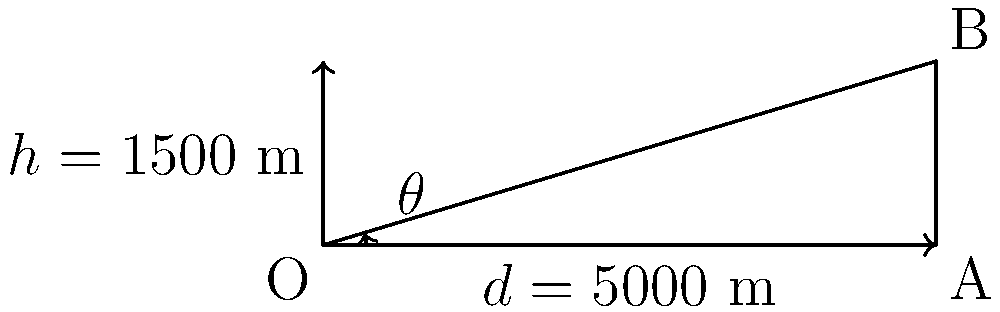An artillery unit needs to fire a long-range shot at a target 5000 meters away. The projectile reaches a maximum height of 1500 meters during its trajectory. Calculate the angle of elevation (θ) required for this shot. Round your answer to the nearest degree. To solve this problem, we'll use trigonometry, specifically the tangent function. Here's the step-by-step solution:

1) In the diagram, we have a right triangle where:
   - The base (d) represents the distance to the target: 5000 m
   - The height (h) represents the maximum projectile height: 1500 m
   - The angle θ at the origin is the angle of elevation we need to find

2) We can use the tangent function to find the angle:

   $\tan(\theta) = \frac{\text{opposite}}{\text{adjacent}} = \frac{h}{d} = \frac{1500}{5000}$

3) To find θ, we need to use the inverse tangent (arctan or tan⁻¹) function:

   $\theta = \tan^{-1}(\frac{1500}{5000})$

4) Calculate:
   $\theta = \tan^{-1}(0.3) \approx 0.2914$ radians

5) Convert radians to degrees:
   $\theta \approx 0.2914 \times \frac{180^{\circ}}{\pi} \approx 16.70^{\circ}$

6) Rounding to the nearest degree:
   $\theta \approx 17^{\circ}$

Therefore, the artillery unit should set their angle of elevation to 17 degrees for this long-range shot.
Answer: $17^{\circ}$ 